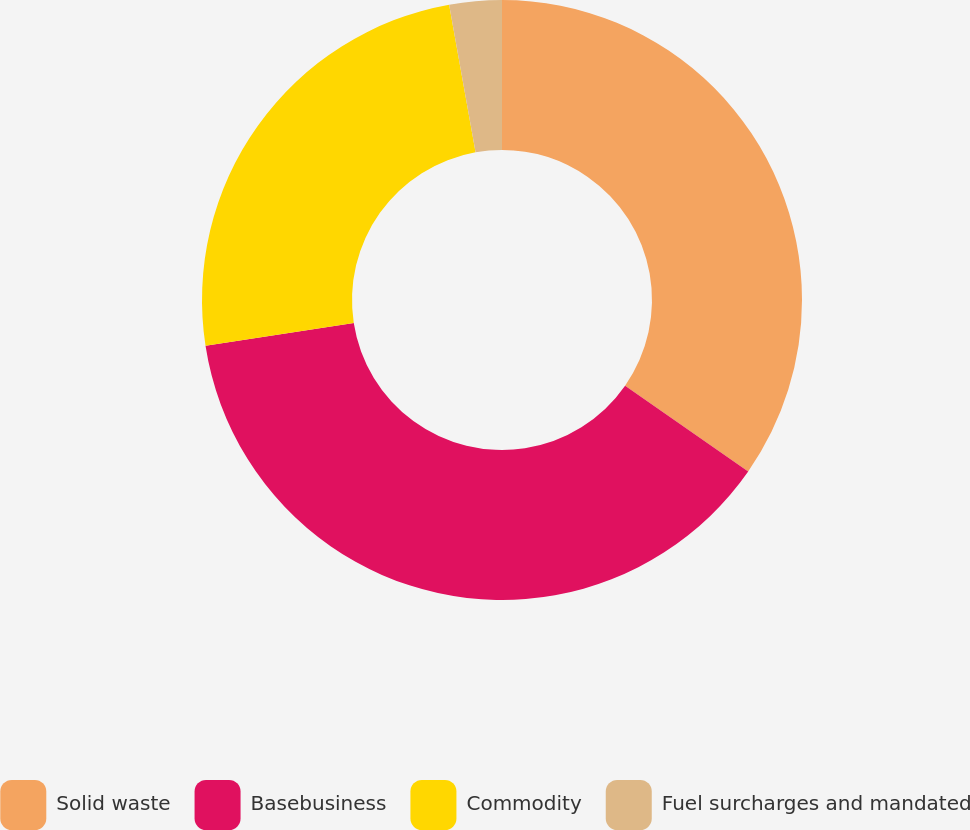<chart> <loc_0><loc_0><loc_500><loc_500><pie_chart><fcel>Solid waste<fcel>Basebusiness<fcel>Commodity<fcel>Fuel surcharges and mandated<nl><fcel>34.68%<fcel>37.88%<fcel>24.62%<fcel>2.82%<nl></chart> 